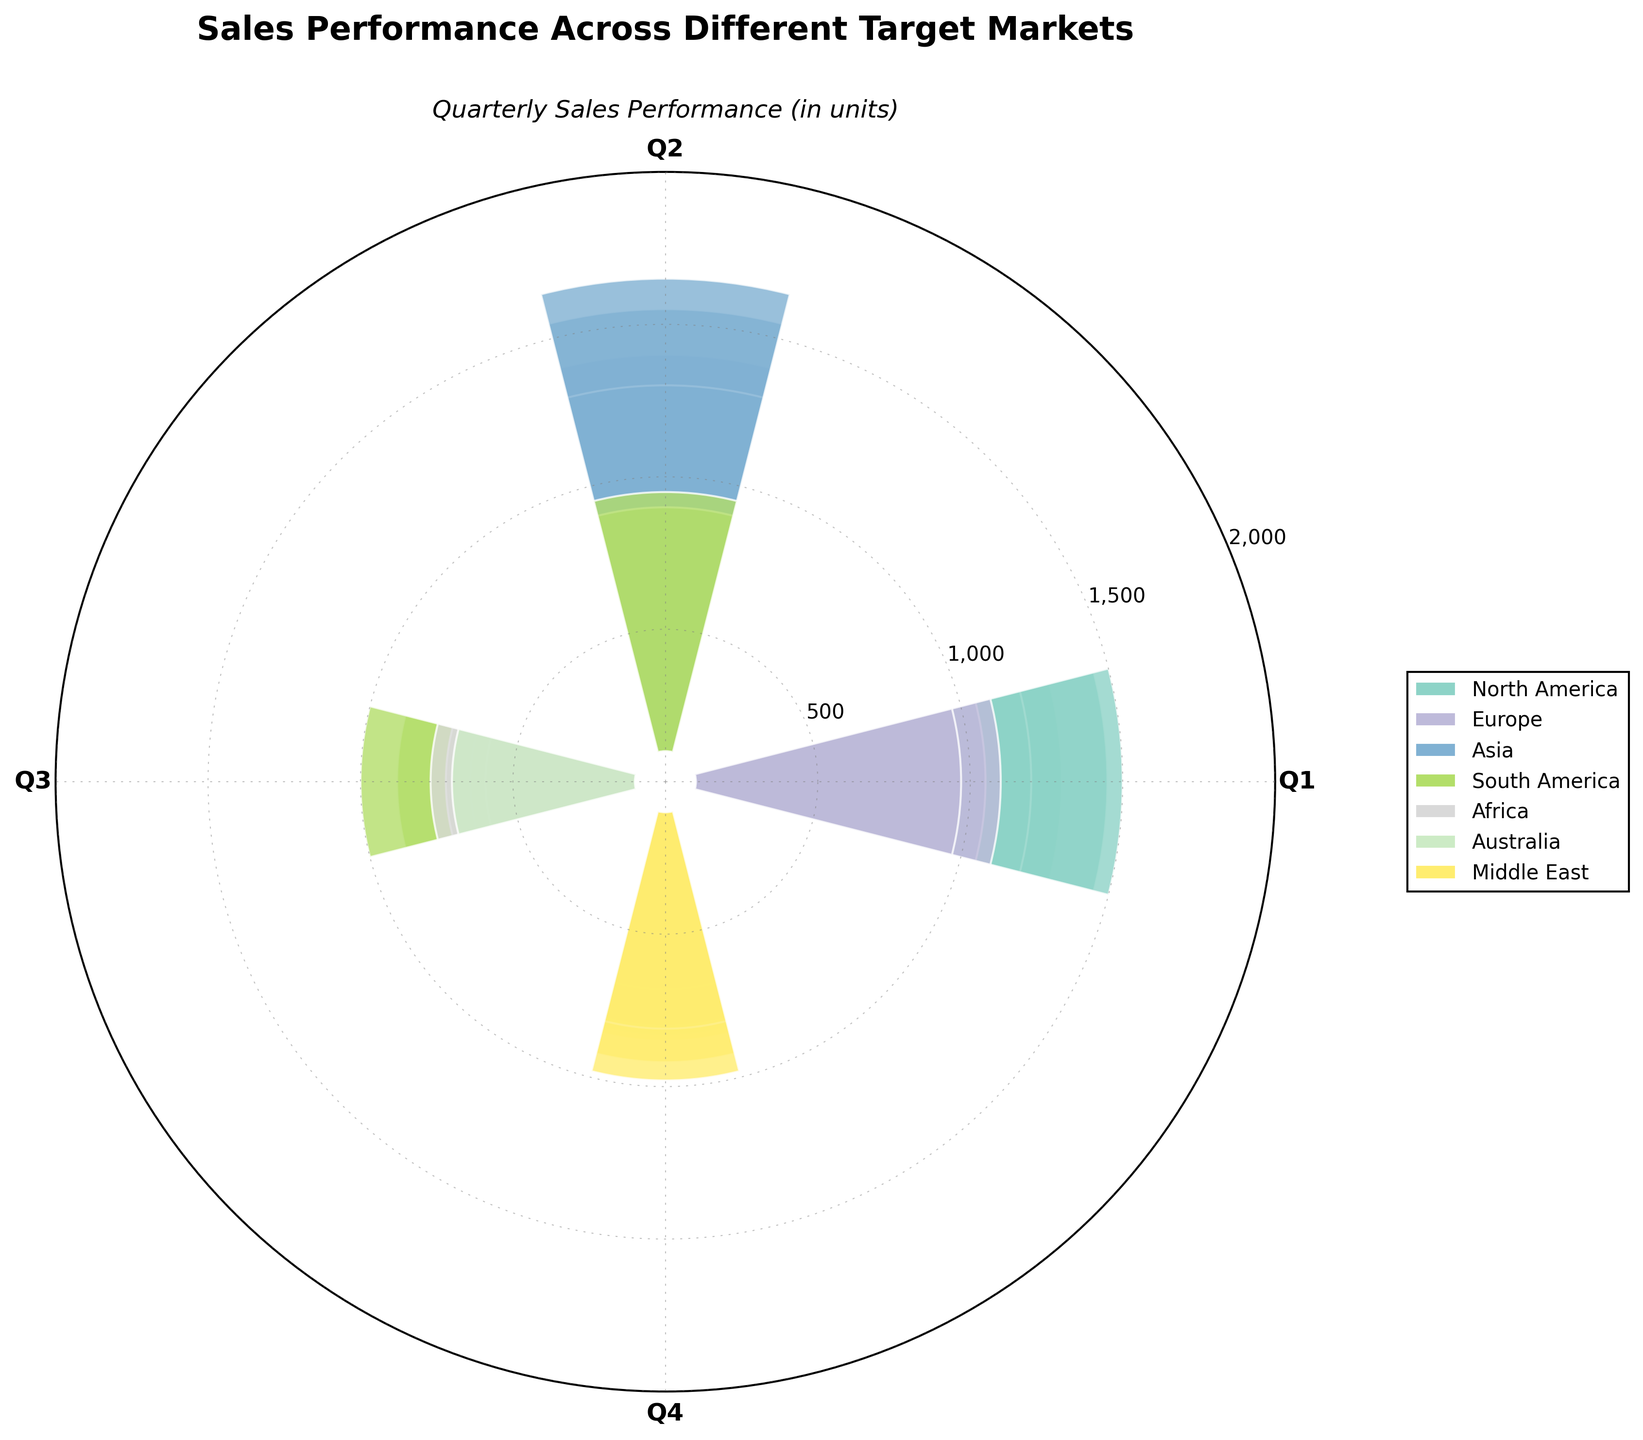What is the title of the figure? The title is typically located at the top of the chart. From the data and code, it is mentioned that the title is "Sales Performance Across Different Target Markets".
Answer: Sales Performance Across Different Target Markets What are the four quarters represented on the chart? The four quarters are the labels on the x-axis, and they are Q1, Q2, Q3, and Q4.
Answer: Q1, Q2, Q3, Q4 Which market had the highest sales in Q4? By looking at the heights of the bars in Q4, Asia had the highest sales in Q4, reaching 1550 units.
Answer: Asia What is the range of sales for Australia across the four quarters? The lowest sales for Australia occur in Q3 (580 units) and the highest in Q4 (730 units). The range is the difference between the highest and lowest values: 730 - 580 = 150.
Answer: 150 Did Africa's sales increase or decrease from Q1 to Q4? Comparing the bar heights for Africa from Q1 (540 units) to Q4 (670 units), we see an increase of 130 units.
Answer: Increased What is the average sales for South America across the four quarters? Adding the sales for South America: 800 (Q1) + 850 (Q2) + 780 (Q3) + 900 (Q4) = 3330, then dividing by the number of quarters: 3330 / 4 = 832.5 units on average.
Answer: 832.5 How do the sales in North America in Q1 compare to those in Europe in Q2? The sales in North America in Q1 are 1200 units, while in Europe in Q2 they are 1000 units. Thus, North America has higher sales by 200 units.
Answer: North America Which market had the most consistent sales across all quarters? A market with consistent sales would have minimal variation across quarters. North America (1200, 1350, 1100, 1400) shows relatively small variation compared to others.
Answer: North America What is the total sales for the Middle East throughout the year? Summing the sales for the Middle East: 750 (Q1) + 820 (Q2) + 710 (Q3) + 880 (Q4) = 3160 units in total.
Answer: 3160 How does the sales pattern of Africa differ from that of Asia? Africa's sales are lower and grow moderately from 540 (Q1) to 670 (Q4), while Asia has overall higher and steadily increasing sales from 1300 (Q1) to 1550 (Q4).
Answer: Africa has lower sales and moderate growth, whereas Asia has higher and increasing sales 